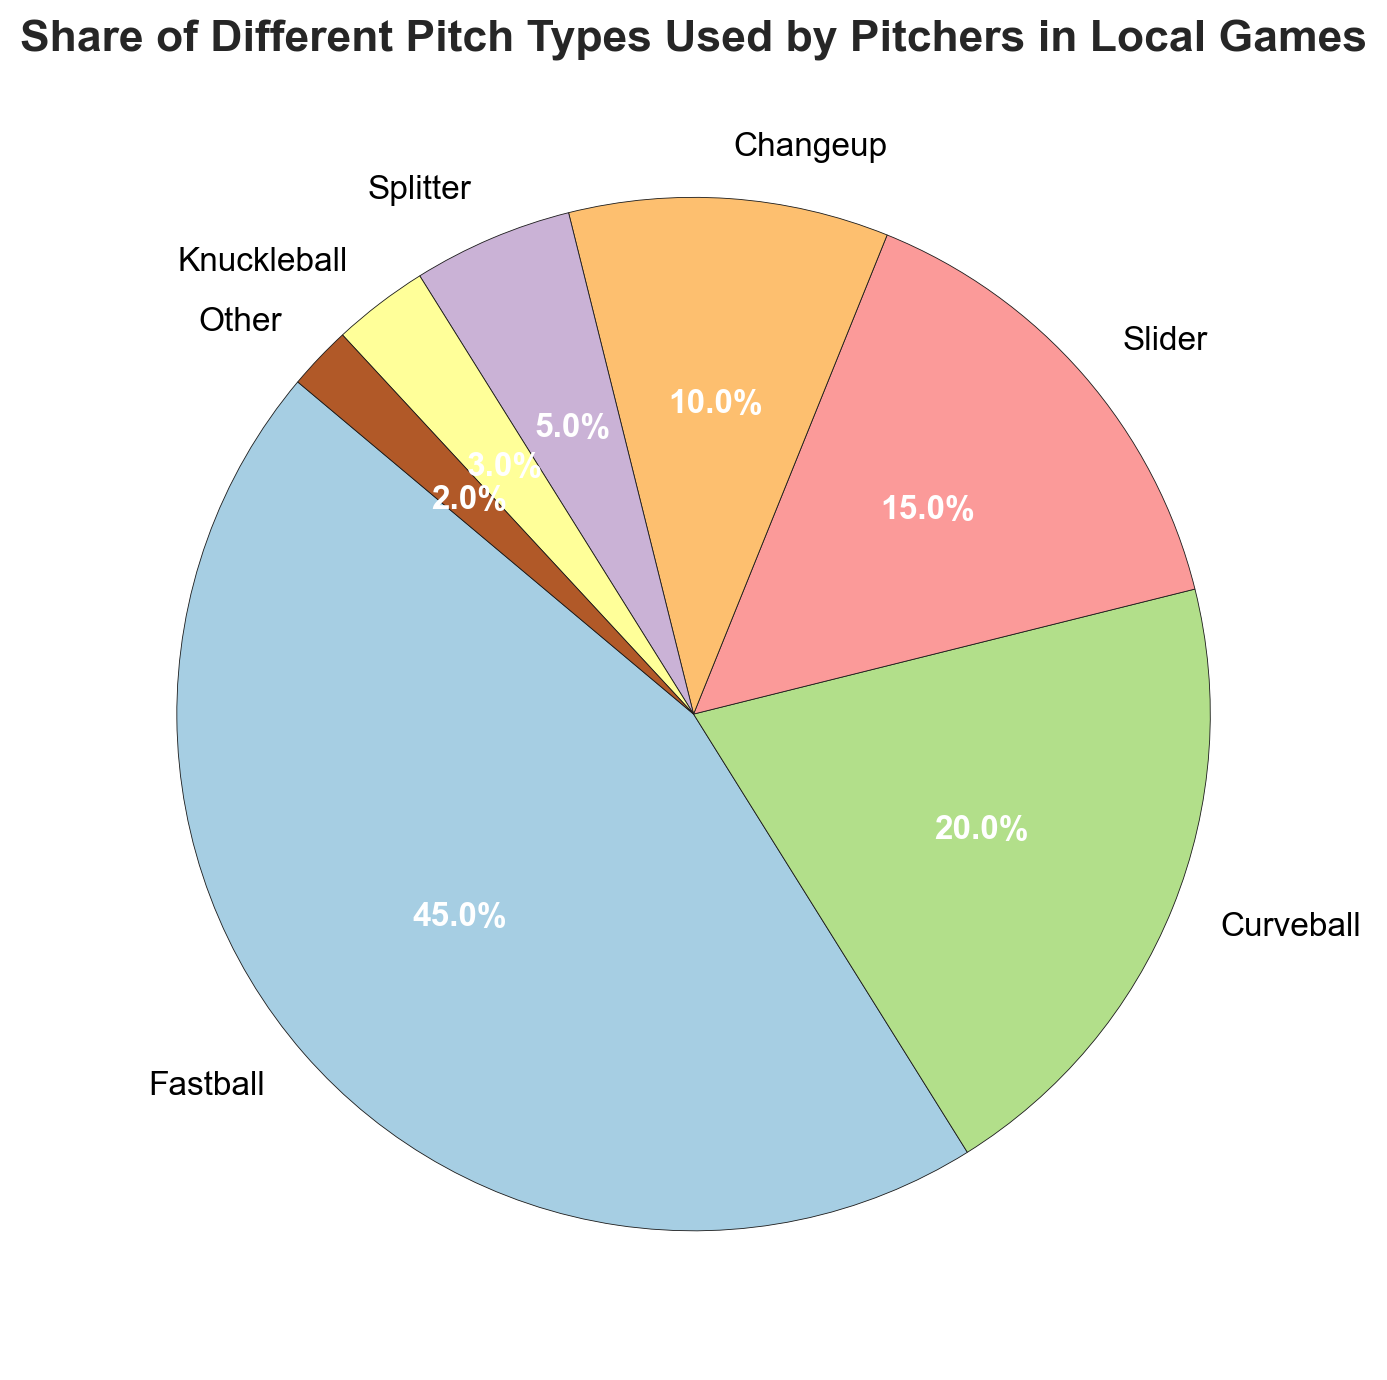Which pitch type is used the most by pitchers in local games? The pie chart shows different pitch types and their shares. The largest segment belongs to Fastball with 45%.
Answer: Fastball Which pitch type has the smallest share? The pie chart indicates various pitch types with their corresponding shares. The smallest segment belongs to 'Other' with 2%.
Answer: Other What is the combined share of Slider and Changeup? To find the combined share, add the share of Slider (15%) and Changeup (10%). So, 15% + 10% = 25%.
Answer: 25% How much more frequently is the Fastball used than the Knuckleball? Subtract the share of Knuckleball (3%) from the share of Fastball (45%). So, 45% - 3% = 42%.
Answer: 42% Which pitch types together make up at least 50% of the total share? From the pie chart, Fastball has 45%, Curveball has 20%, and Slider has 15%. Fastball and Curveball together make 45% + 20% = 65%, which is already more than 50%.
Answer: Fastball and Curveball How does the share of Changeup compare to that of Splitter? The pie chart shows that Changeup has a share of 10% and Splitter has 5%. Since 10% is greater than 5%, Changeup is used more frequently than Splitter.
Answer: Changeup is used more What percentage of pitch types fall into the 'Other' category? The pie chart lists 'Other' as one of the categories with a share percentage of 2%.
Answer: 2% Are there any pitch types whose combined share equals the share of Fastball? The share of the Fastball is 45%. Curveball (20%) and Slider (15%) together make up 35%, adding Changeup (10%) gives 45%, which equals the Fastball’s share.
Answer: Curveball, Slider, and Changeup What are the two least used pitch types, and what is their combined share? The pie chart shows that Knuckleball (3%) and Other (2%) are the least used. Their combined share is 3% + 2% = 5%.
Answer: Knuckleball and Other, 5% How significant is the difference in the usage between Fastball and Curveball? To find the difference, subtract the share of Curveball (20%) from the share of Fastball (45%). So, 45% - 20% = 25%.
Answer: 25% 